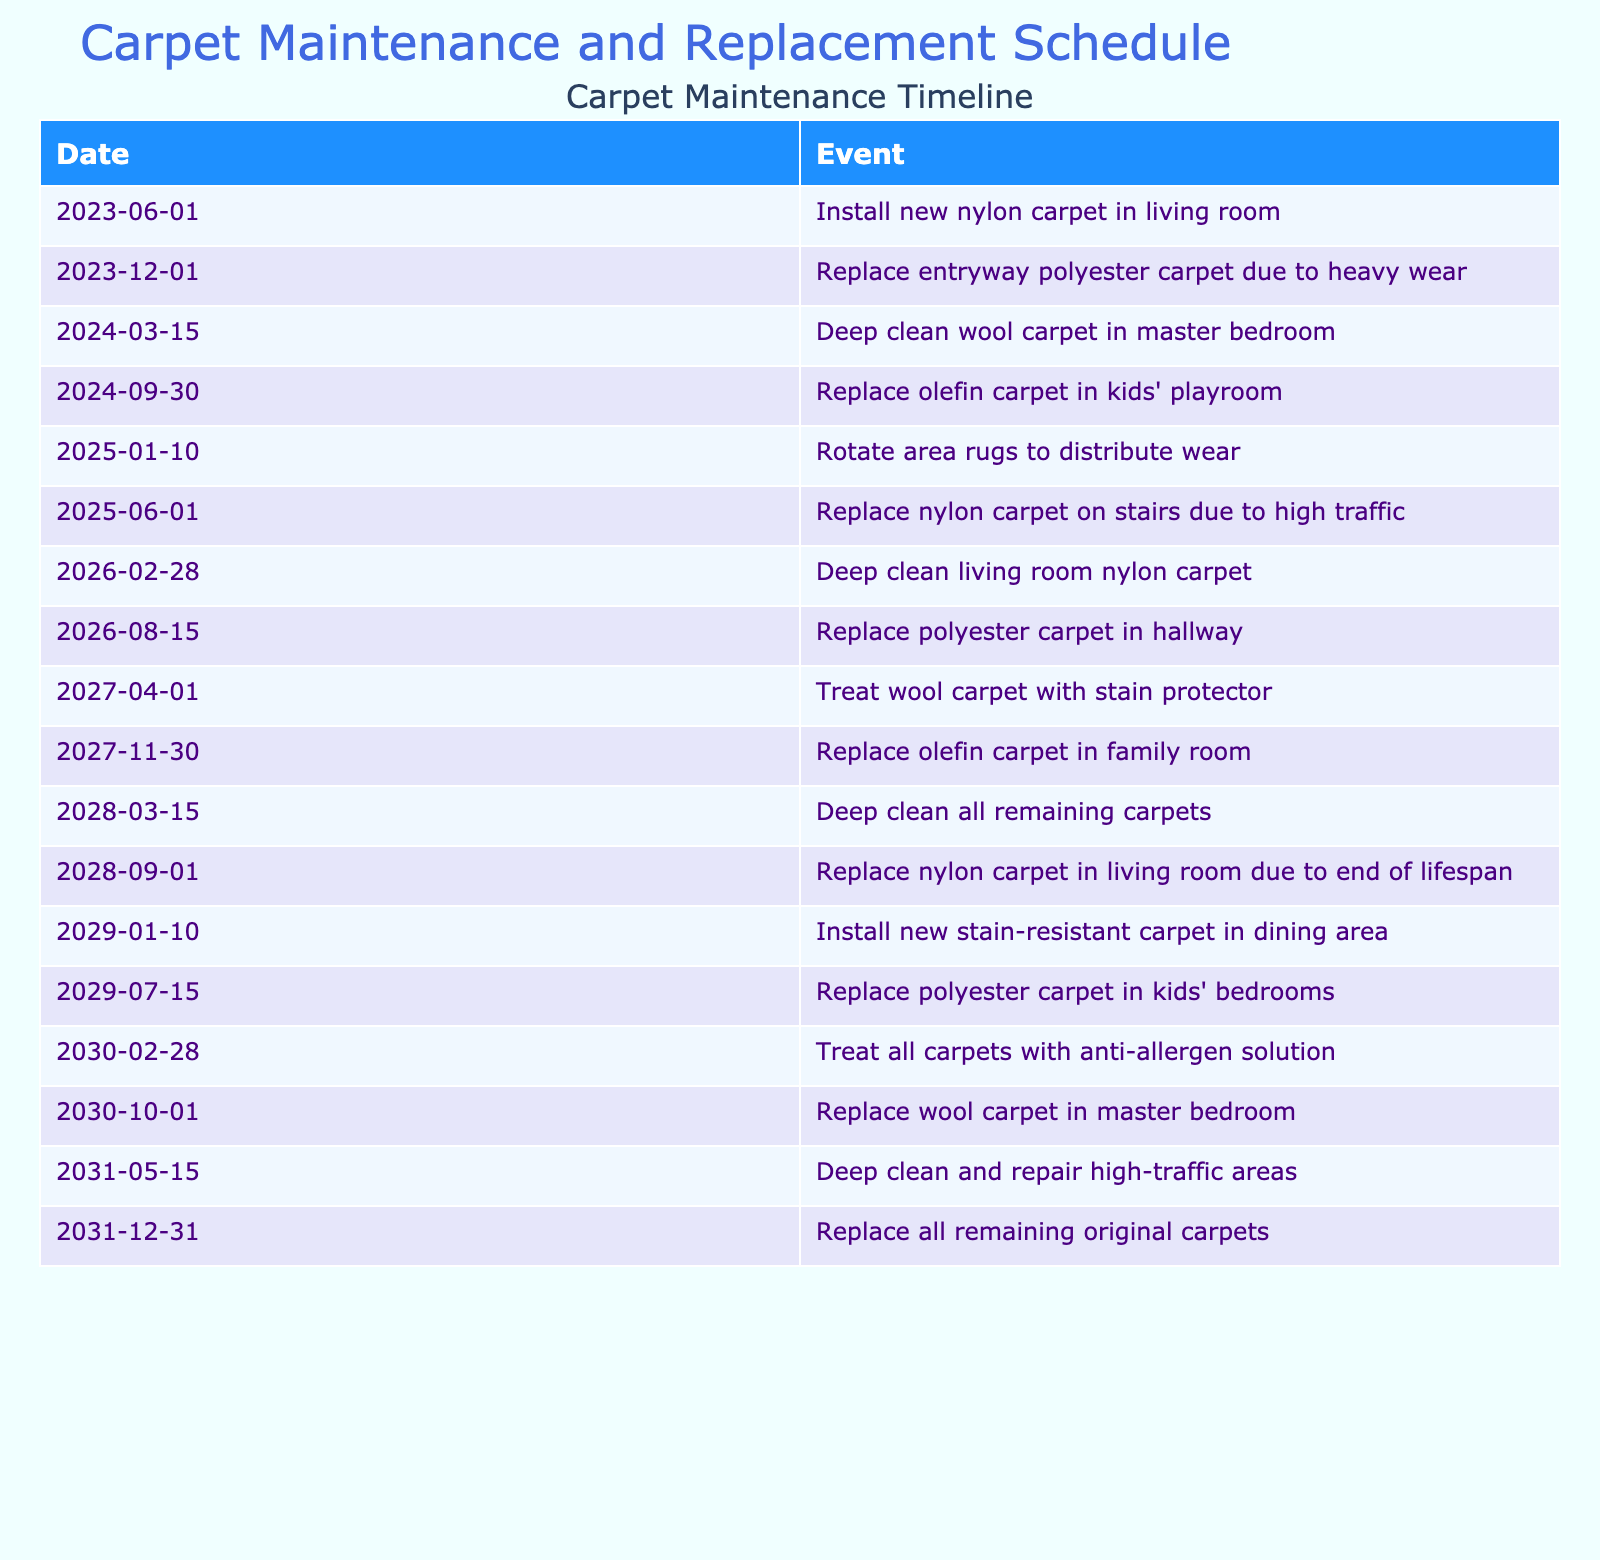What date was the new nylon carpet installed in the living room? The table specifies that the event of installing a new nylon carpet in the living room occurred on 2023-06-01.
Answer: 2023-06-01 When was the olefin carpet in the kids' playroom replaced? According to the table, the olefin carpet in the kids' playroom was replaced on 2024-09-30.
Answer: 2024-09-30 How many carpets were listed for replacement in 2025? The table lists two replacement events in 2025: the nylon carpet on stairs in June and the polyester carpet in kids' bedrooms in July. Thus, there were 2 replacement instances in 2025.
Answer: 2 Is the wool carpet in the master bedroom replaced before the olefin carpet in the family room? The wool carpet in the master bedroom is replaced in October 2030, while the olefin carpet in the family room is replaced in November 2027. Therefore, the statement is false.
Answer: No How many times was the nylon carpet deep cleaned? The table indicates that the nylon carpet was deep cleaned on two occasions: first on 2026-02-28 and as part of cleaning all remaining carpets on 2028-03-15.
Answer: 2 What is the time span between the installation of the new stain-resistant carpet in the dining area and the last replacement of the original carpets? The new stain-resistant carpet was installed on 2029-01-10, and the last replacement of the original carpets was on 2031-12-31. The time span between these dates is 2 years and 11 months, or 35 months.
Answer: 35 months Which carpet type was replaced most frequently according to the table? By reviewing the events, the nylon carpet appears to be replaced on three separate occasions: once in June 2025, again in September 2028, and the third time no specific date is recorded, but it's stated as the original carpets are replaced in December 2031. Therefore, nylon has the highest replacement frequency.
Answer: Nylon carpet What was the latest carpet maintenance or replacement event listed? The latest event is the replacement of all remaining original carpets on 2031-12-31. This indicates the end of the original carpet timeline in the table.
Answer: 2031-12-31 